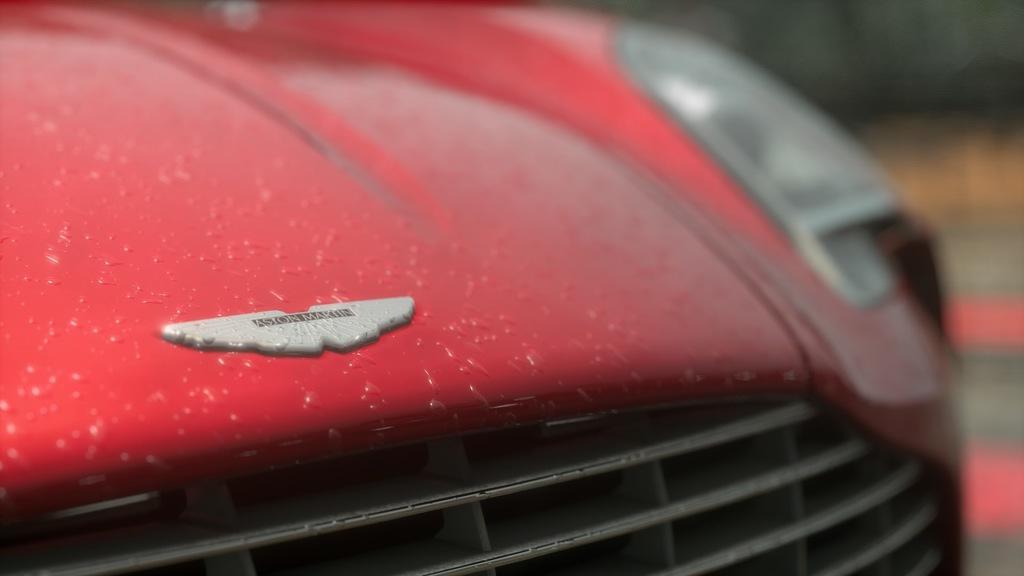In one or two sentences, can you explain what this image depicts? This is a zoomed in picture. In the foreground we can see a red color object seems to be the car and we can see the logo and the text on the logo. The background of the image is blurry. 